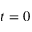Convert formula to latex. <formula><loc_0><loc_0><loc_500><loc_500>t = 0</formula> 